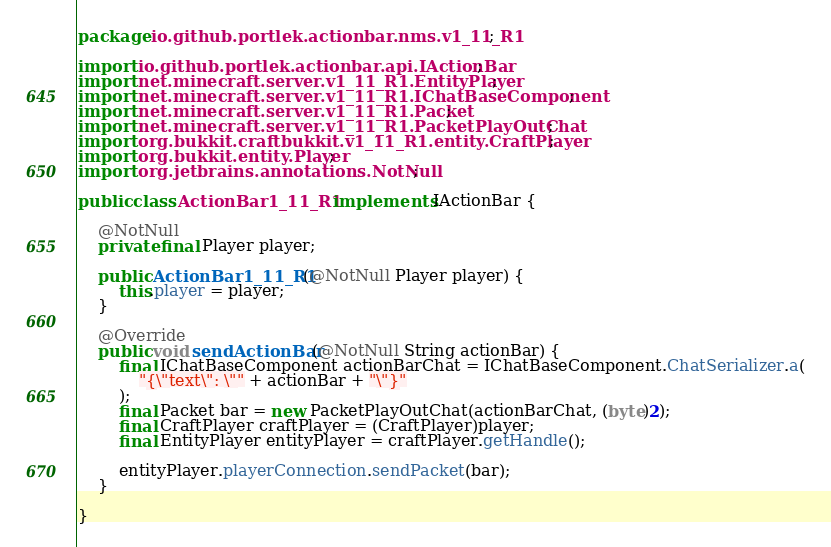Convert code to text. <code><loc_0><loc_0><loc_500><loc_500><_Java_>package io.github.portlek.actionbar.nms.v1_11_R1;

import io.github.portlek.actionbar.api.IActionBar;
import net.minecraft.server.v1_11_R1.EntityPlayer;
import net.minecraft.server.v1_11_R1.IChatBaseComponent;
import net.minecraft.server.v1_11_R1.Packet;
import net.minecraft.server.v1_11_R1.PacketPlayOutChat;
import org.bukkit.craftbukkit.v1_11_R1.entity.CraftPlayer;
import org.bukkit.entity.Player;
import org.jetbrains.annotations.NotNull;

public class ActionBar1_11_R1 implements IActionBar {

    @NotNull
    private final Player player;

    public ActionBar1_11_R1(@NotNull Player player) {
        this.player = player;
    }

    @Override
    public void sendActionBar(@NotNull String actionBar) {
        final IChatBaseComponent actionBarChat = IChatBaseComponent.ChatSerializer.a(
            "{\"text\": \"" + actionBar + "\"}"
        );
        final Packet bar = new PacketPlayOutChat(actionBarChat, (byte)2);
        final CraftPlayer craftPlayer = (CraftPlayer)player;
        final EntityPlayer entityPlayer = craftPlayer.getHandle();

        entityPlayer.playerConnection.sendPacket(bar);
    }

}
</code> 